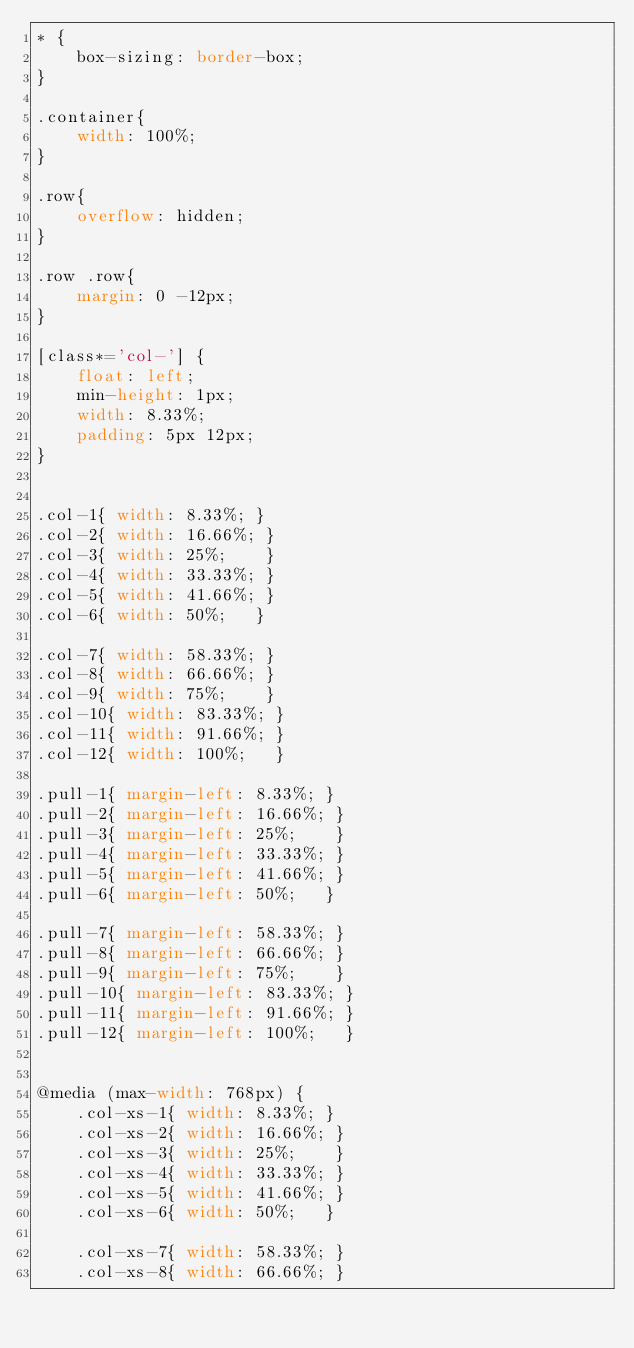<code> <loc_0><loc_0><loc_500><loc_500><_CSS_>* {
    box-sizing: border-box;
}

.container{
    width: 100%;
}

.row{
    overflow: hidden;
}

.row .row{
    margin: 0 -12px;
}

[class*='col-'] {
    float: left;
    min-height: 1px;
    width: 8.33%;
    padding: 5px 12px;
}


.col-1{ width: 8.33%; }
.col-2{ width: 16.66%; }
.col-3{ width: 25%;    }
.col-4{ width: 33.33%; }
.col-5{ width: 41.66%; }
.col-6{ width: 50%;   }

.col-7{ width: 58.33%; }
.col-8{ width: 66.66%; }
.col-9{ width: 75%;    }
.col-10{ width: 83.33%; }
.col-11{ width: 91.66%; }
.col-12{ width: 100%;   }

.pull-1{ margin-left: 8.33%; }
.pull-2{ margin-left: 16.66%; }
.pull-3{ margin-left: 25%;    }
.pull-4{ margin-left: 33.33%; }
.pull-5{ margin-left: 41.66%; }
.pull-6{ margin-left: 50%;   }

.pull-7{ margin-left: 58.33%; }
.pull-8{ margin-left: 66.66%; }
.pull-9{ margin-left: 75%;    }
.pull-10{ margin-left: 83.33%; }
.pull-11{ margin-left: 91.66%; }
.pull-12{ margin-left: 100%;   }


@media (max-width: 768px) {
    .col-xs-1{ width: 8.33%; }
    .col-xs-2{ width: 16.66%; }
    .col-xs-3{ width: 25%;    }
    .col-xs-4{ width: 33.33%; }
    .col-xs-5{ width: 41.66%; }
    .col-xs-6{ width: 50%;   }

    .col-xs-7{ width: 58.33%; }
    .col-xs-8{ width: 66.66%; }</code> 